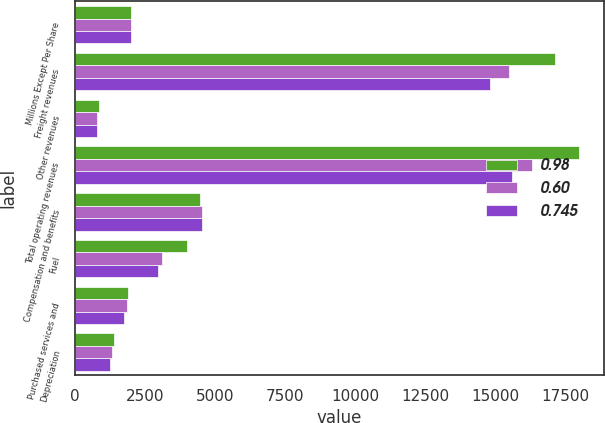Convert chart. <chart><loc_0><loc_0><loc_500><loc_500><stacked_bar_chart><ecel><fcel>Millions Except Per Share<fcel>Freight revenues<fcel>Other revenues<fcel>Total operating revenues<fcel>Compensation and benefits<fcel>Fuel<fcel>Purchased services and<fcel>Depreciation<nl><fcel>0.98<fcel>2008<fcel>17118<fcel>852<fcel>17970<fcel>4457<fcel>3983<fcel>1902<fcel>1387<nl><fcel>0.6<fcel>2007<fcel>15486<fcel>797<fcel>16283<fcel>4526<fcel>3104<fcel>1856<fcel>1321<nl><fcel>0.745<fcel>2006<fcel>14791<fcel>787<fcel>15578<fcel>4535<fcel>2968<fcel>1756<fcel>1237<nl></chart> 